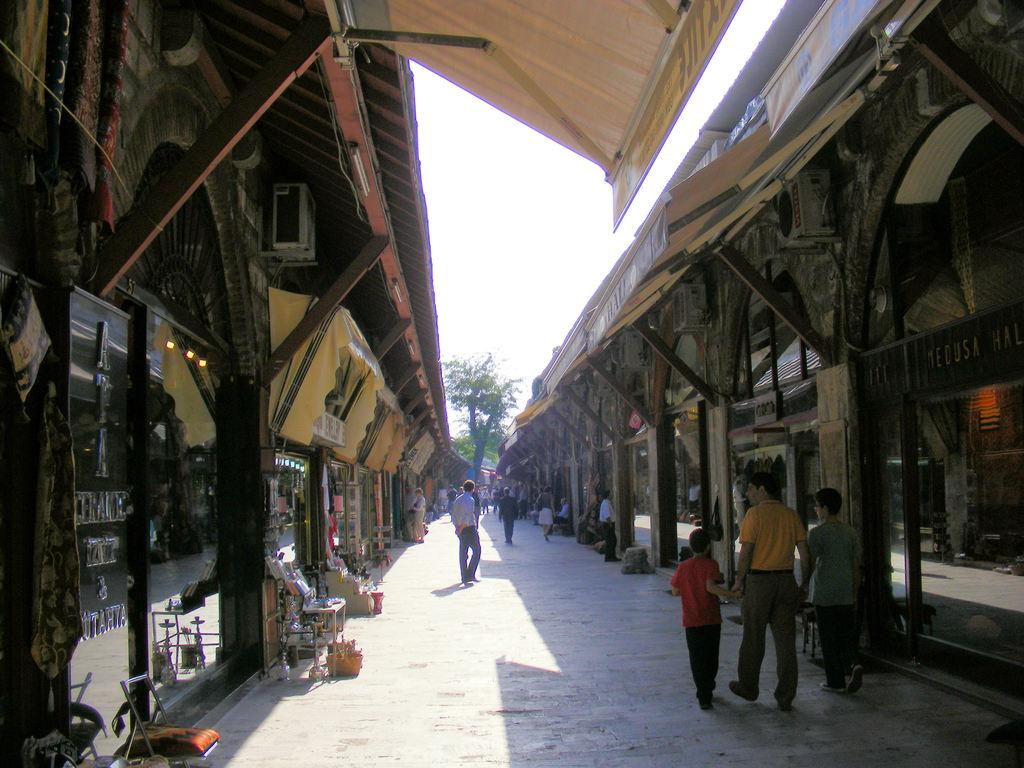What can be seen in the sky in the image? The sky is visible in the image. What type of natural vegetation is present in the image? There are trees in the image. What type of structures can be seen in the image? There are stalls and iron bars visible in the image. What type of appliance is present in the image? Air conditioners are visible in the image. What type of furniture is present in the image? There is a chair in the image. What type of activity is happening in the image? Persons are walking on the road in the image. How many children are playing with the servant at night in the image? There are no children or servants present in the image, and the time of day is not specified. 